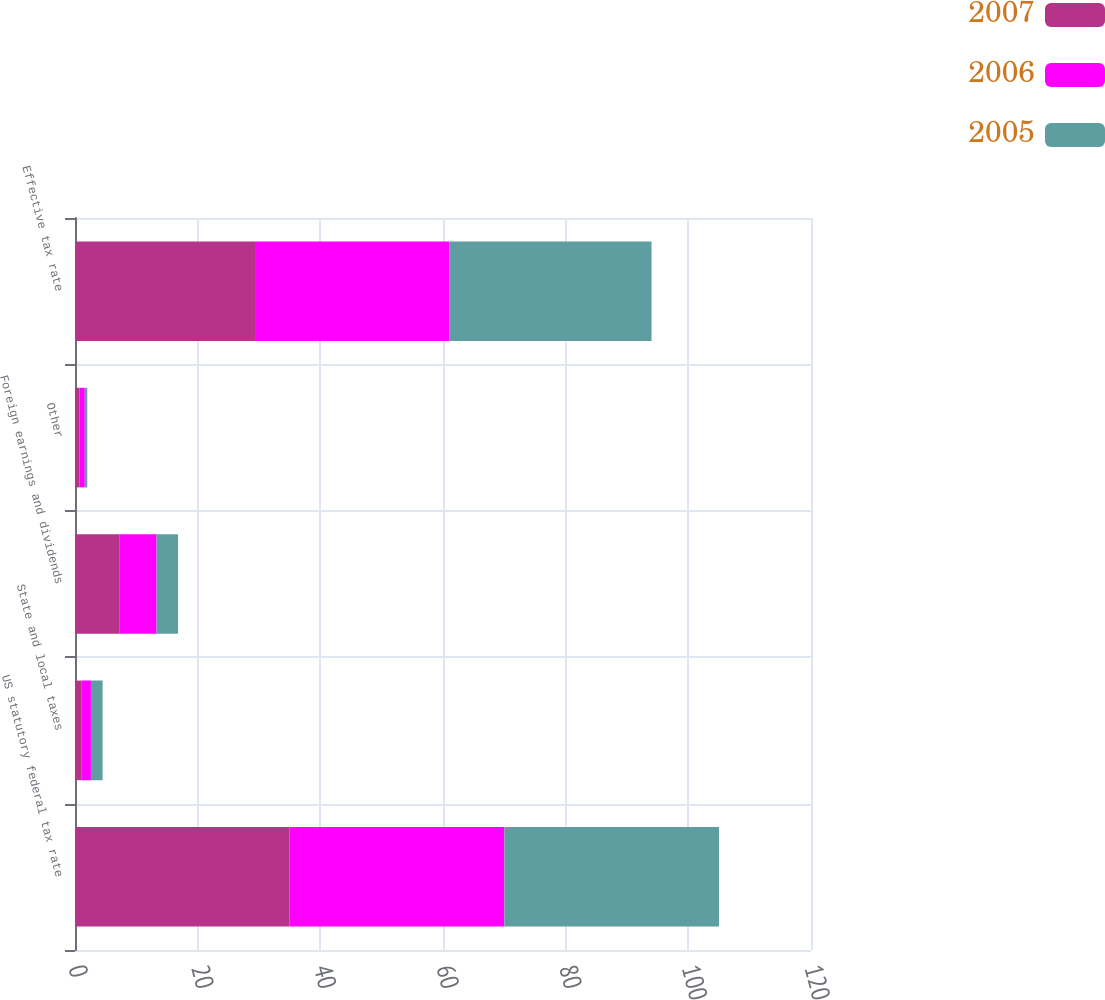<chart> <loc_0><loc_0><loc_500><loc_500><stacked_bar_chart><ecel><fcel>US statutory federal tax rate<fcel>State and local taxes<fcel>Foreign earnings and dividends<fcel>Other<fcel>Effective tax rate<nl><fcel>2007<fcel>35<fcel>1.1<fcel>7.3<fcel>0.7<fcel>29.5<nl><fcel>2006<fcel>35<fcel>1.5<fcel>6<fcel>0.9<fcel>31.5<nl><fcel>2005<fcel>35<fcel>1.9<fcel>3.5<fcel>0.4<fcel>33<nl></chart> 